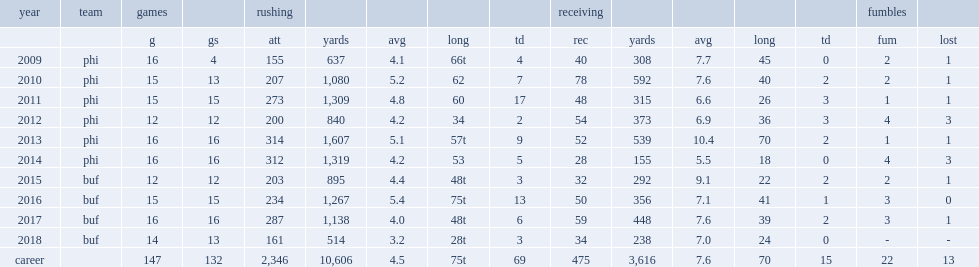How many rushing yards did mccoy get in 2013? 1607.0. Can you give me this table as a dict? {'header': ['year', 'team', 'games', '', 'rushing', '', '', '', '', 'receiving', '', '', '', '', 'fumbles', ''], 'rows': [['', '', 'g', 'gs', 'att', 'yards', 'avg', 'long', 'td', 'rec', 'yards', 'avg', 'long', 'td', 'fum', 'lost'], ['2009', 'phi', '16', '4', '155', '637', '4.1', '66t', '4', '40', '308', '7.7', '45', '0', '2', '1'], ['2010', 'phi', '15', '13', '207', '1,080', '5.2', '62', '7', '78', '592', '7.6', '40', '2', '2', '1'], ['2011', 'phi', '15', '15', '273', '1,309', '4.8', '60', '17', '48', '315', '6.6', '26', '3', '1', '1'], ['2012', 'phi', '12', '12', '200', '840', '4.2', '34', '2', '54', '373', '6.9', '36', '3', '4', '3'], ['2013', 'phi', '16', '16', '314', '1,607', '5.1', '57t', '9', '52', '539', '10.4', '70', '2', '1', '1'], ['2014', 'phi', '16', '16', '312', '1,319', '4.2', '53', '5', '28', '155', '5.5', '18', '0', '4', '3'], ['2015', 'buf', '12', '12', '203', '895', '4.4', '48t', '3', '32', '292', '9.1', '22', '2', '2', '1'], ['2016', 'buf', '15', '15', '234', '1,267', '5.4', '75t', '13', '50', '356', '7.1', '41', '1', '3', '0'], ['2017', 'buf', '16', '16', '287', '1,138', '4.0', '48t', '6', '59', '448', '7.6', '39', '2', '3', '1'], ['2018', 'buf', '14', '13', '161', '514', '3.2', '28t', '3', '34', '238', '7.0', '24', '0', '-', '-'], ['career', '', '147', '132', '2,346', '10,606', '4.5', '75t', '69', '475', '3,616', '7.6', '70', '15', '22', '13']]} How many rushing yards did lesean mccoy get in 2016? 1267.0. 